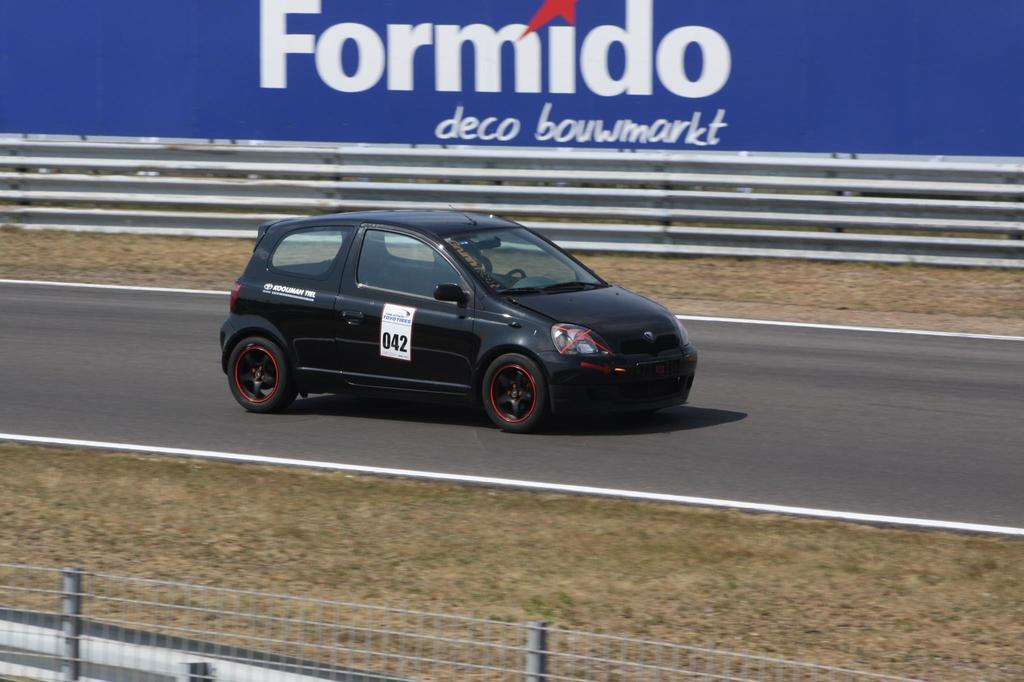What is the main subject of the image? The main subject of the image is a car on the road. What can be seen at the bottom of the image? There is fencing at the bottom of the image. What else is visible in the background of the image? There is an advertisement in the background of the image. What type of pot is being used to hold the cup in the image? There is no pot or cup present in the image. What color is the skirt worn by the person in the image? There is no person or skirt present in the image. 